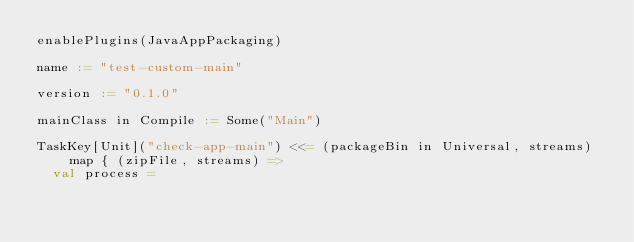Convert code to text. <code><loc_0><loc_0><loc_500><loc_500><_Scala_>enablePlugins(JavaAppPackaging)

name := "test-custom-main"

version := "0.1.0"

mainClass in Compile := Some("Main")

TaskKey[Unit]("check-app-main") <<= (packageBin in Universal, streams) map { (zipFile, streams) =>
  val process =</code> 